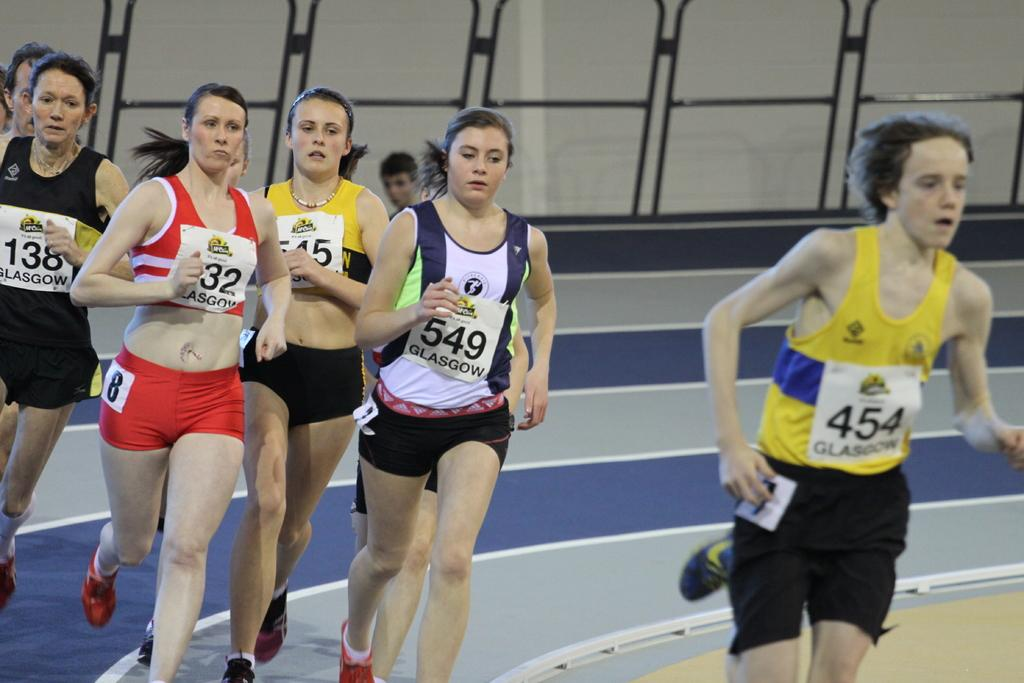<image>
Summarize the visual content of the image. A group of runners with number 549 and 454 on their jersey. 